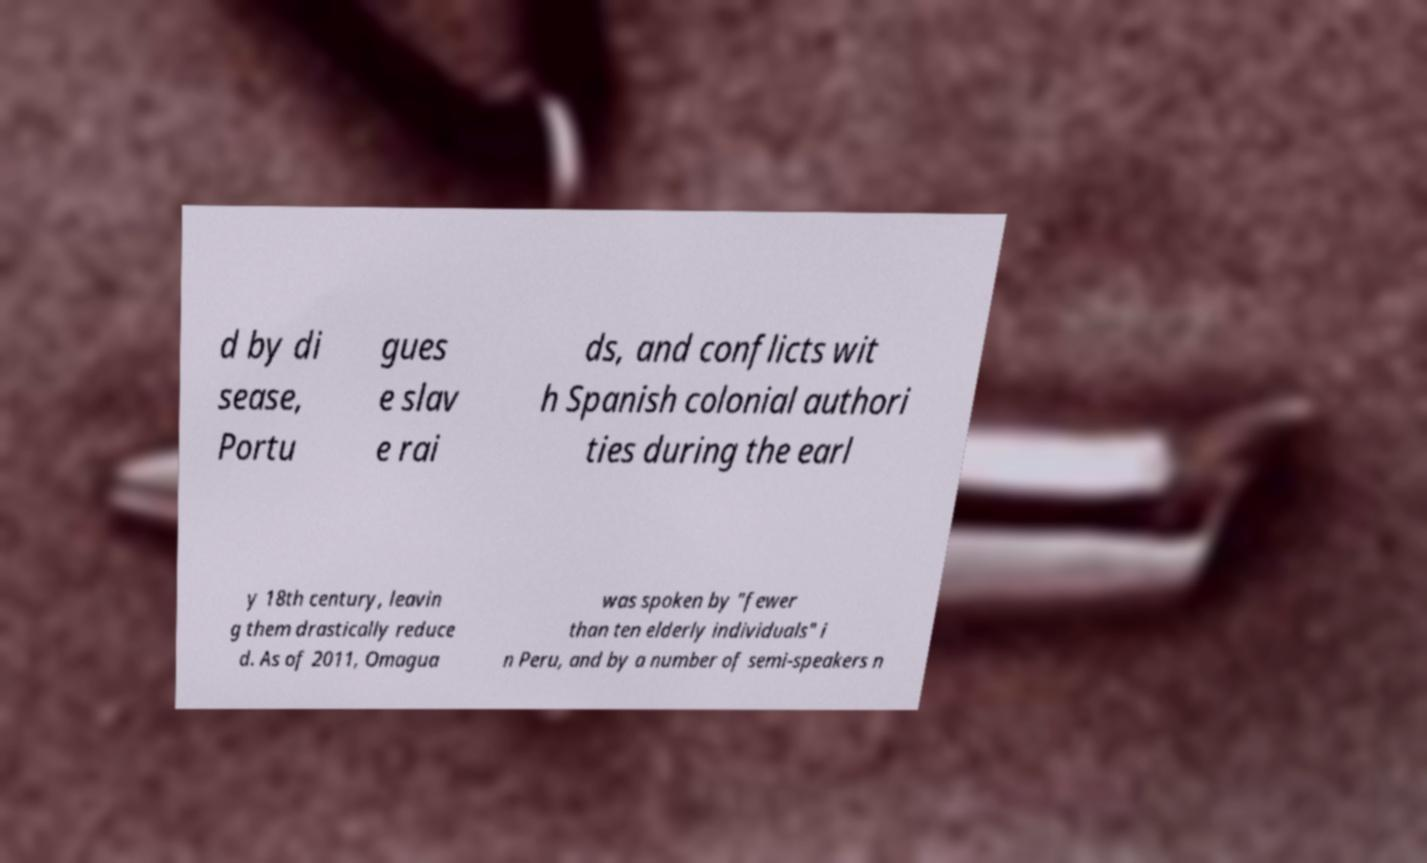Could you extract and type out the text from this image? d by di sease, Portu gues e slav e rai ds, and conflicts wit h Spanish colonial authori ties during the earl y 18th century, leavin g them drastically reduce d. As of 2011, Omagua was spoken by "fewer than ten elderly individuals" i n Peru, and by a number of semi-speakers n 